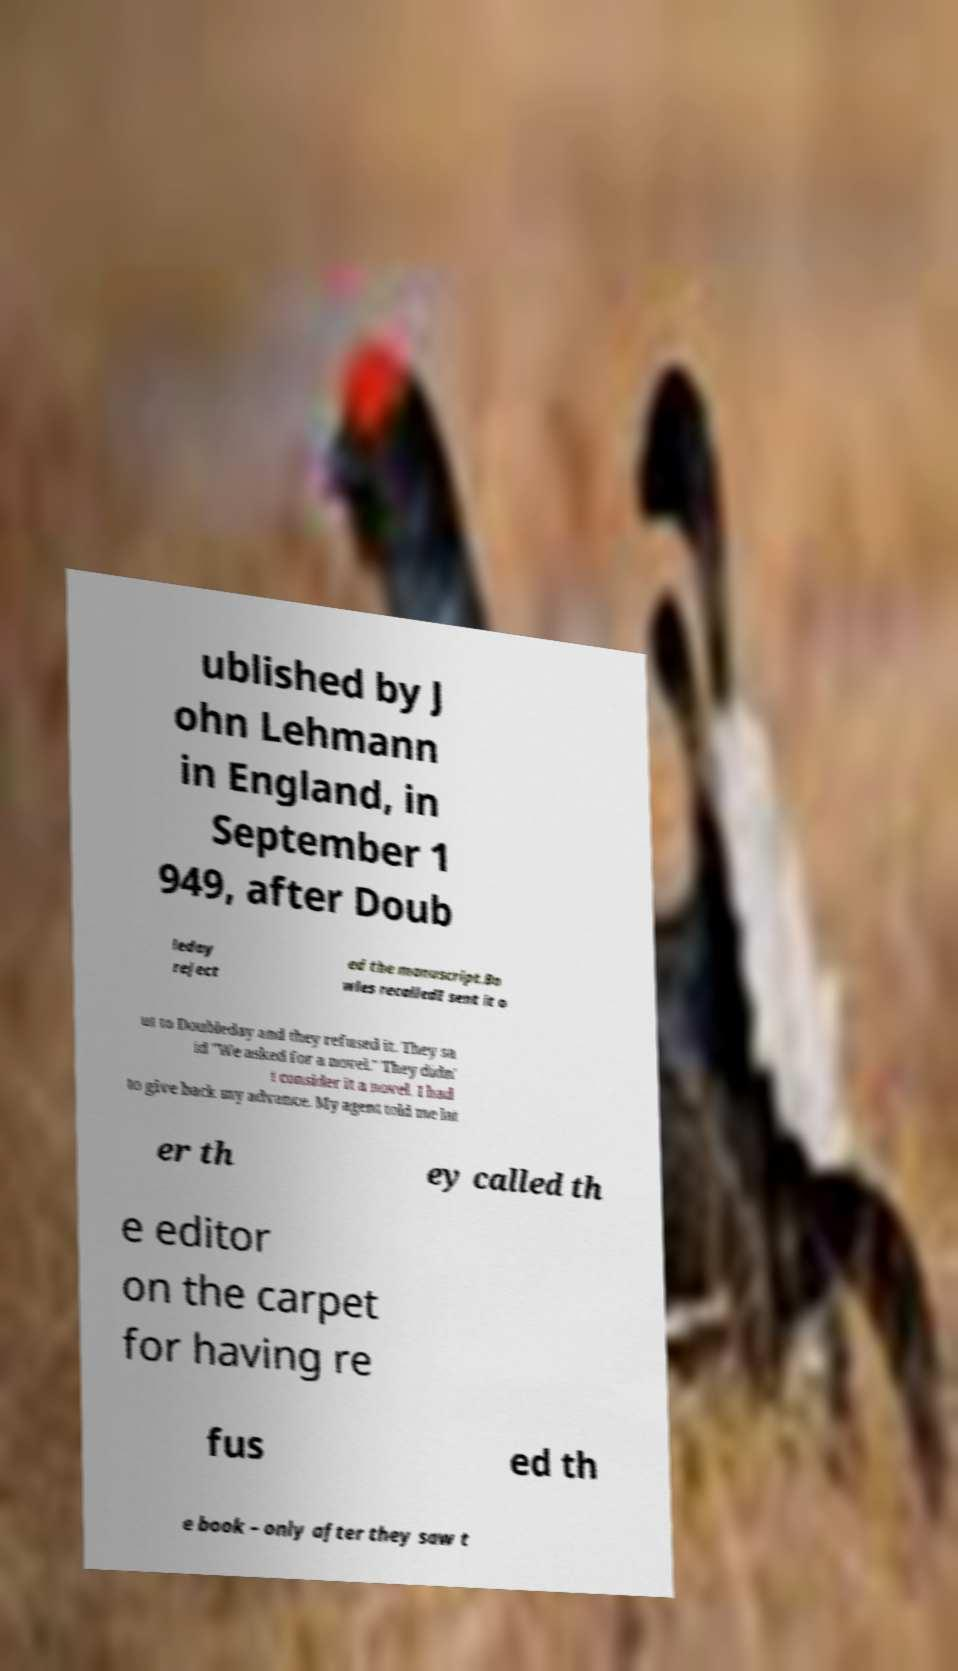Could you assist in decoding the text presented in this image and type it out clearly? ublished by J ohn Lehmann in England, in September 1 949, after Doub leday reject ed the manuscript.Bo wles recalledI sent it o ut to Doubleday and they refused it. They sa id "We asked for a novel." They didn' t consider it a novel. I had to give back my advance. My agent told me lat er th ey called th e editor on the carpet for having re fus ed th e book – only after they saw t 